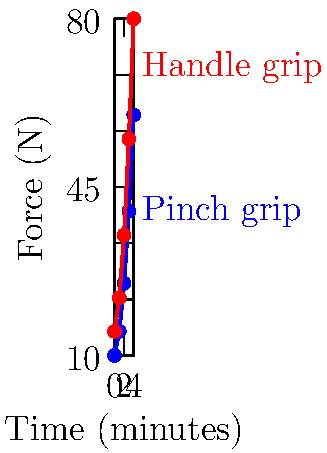Based on the graph showing force distribution over time for different knife grips while chopping vegetables, which grip requires less force initially but leads to more fatigue over time? To answer this question, let's analyze the graph step-by-step:

1. The graph shows two lines representing different knife grips: blue for pinch grip and red for handle grip.

2. The x-axis represents time in minutes, while the y-axis represents force in Newtons (N).

3. At the beginning of the chopping process (t = 0):
   - Pinch grip (blue line) starts at about 10 N
   - Handle grip (red line) starts at about 15 N

4. As time progresses, both lines show an increase in force, indicating fatigue:
   - Pinch grip increases more slowly
   - Handle grip increases more rapidly

5. By the end of the graph (t = 4 minutes):
   - Pinch grip reaches about 60 N
   - Handle grip reaches about 80 N

6. Comparing the two grips:
   - Pinch grip requires less force initially (10 N vs 15 N)
   - Handle grip shows a steeper increase, indicating more rapid fatigue

Therefore, the pinch grip requires less force initially but leads to more fatigue over time, as evidenced by the blue line starting lower but increasing steadily throughout the chopping process.
Answer: Pinch grip 